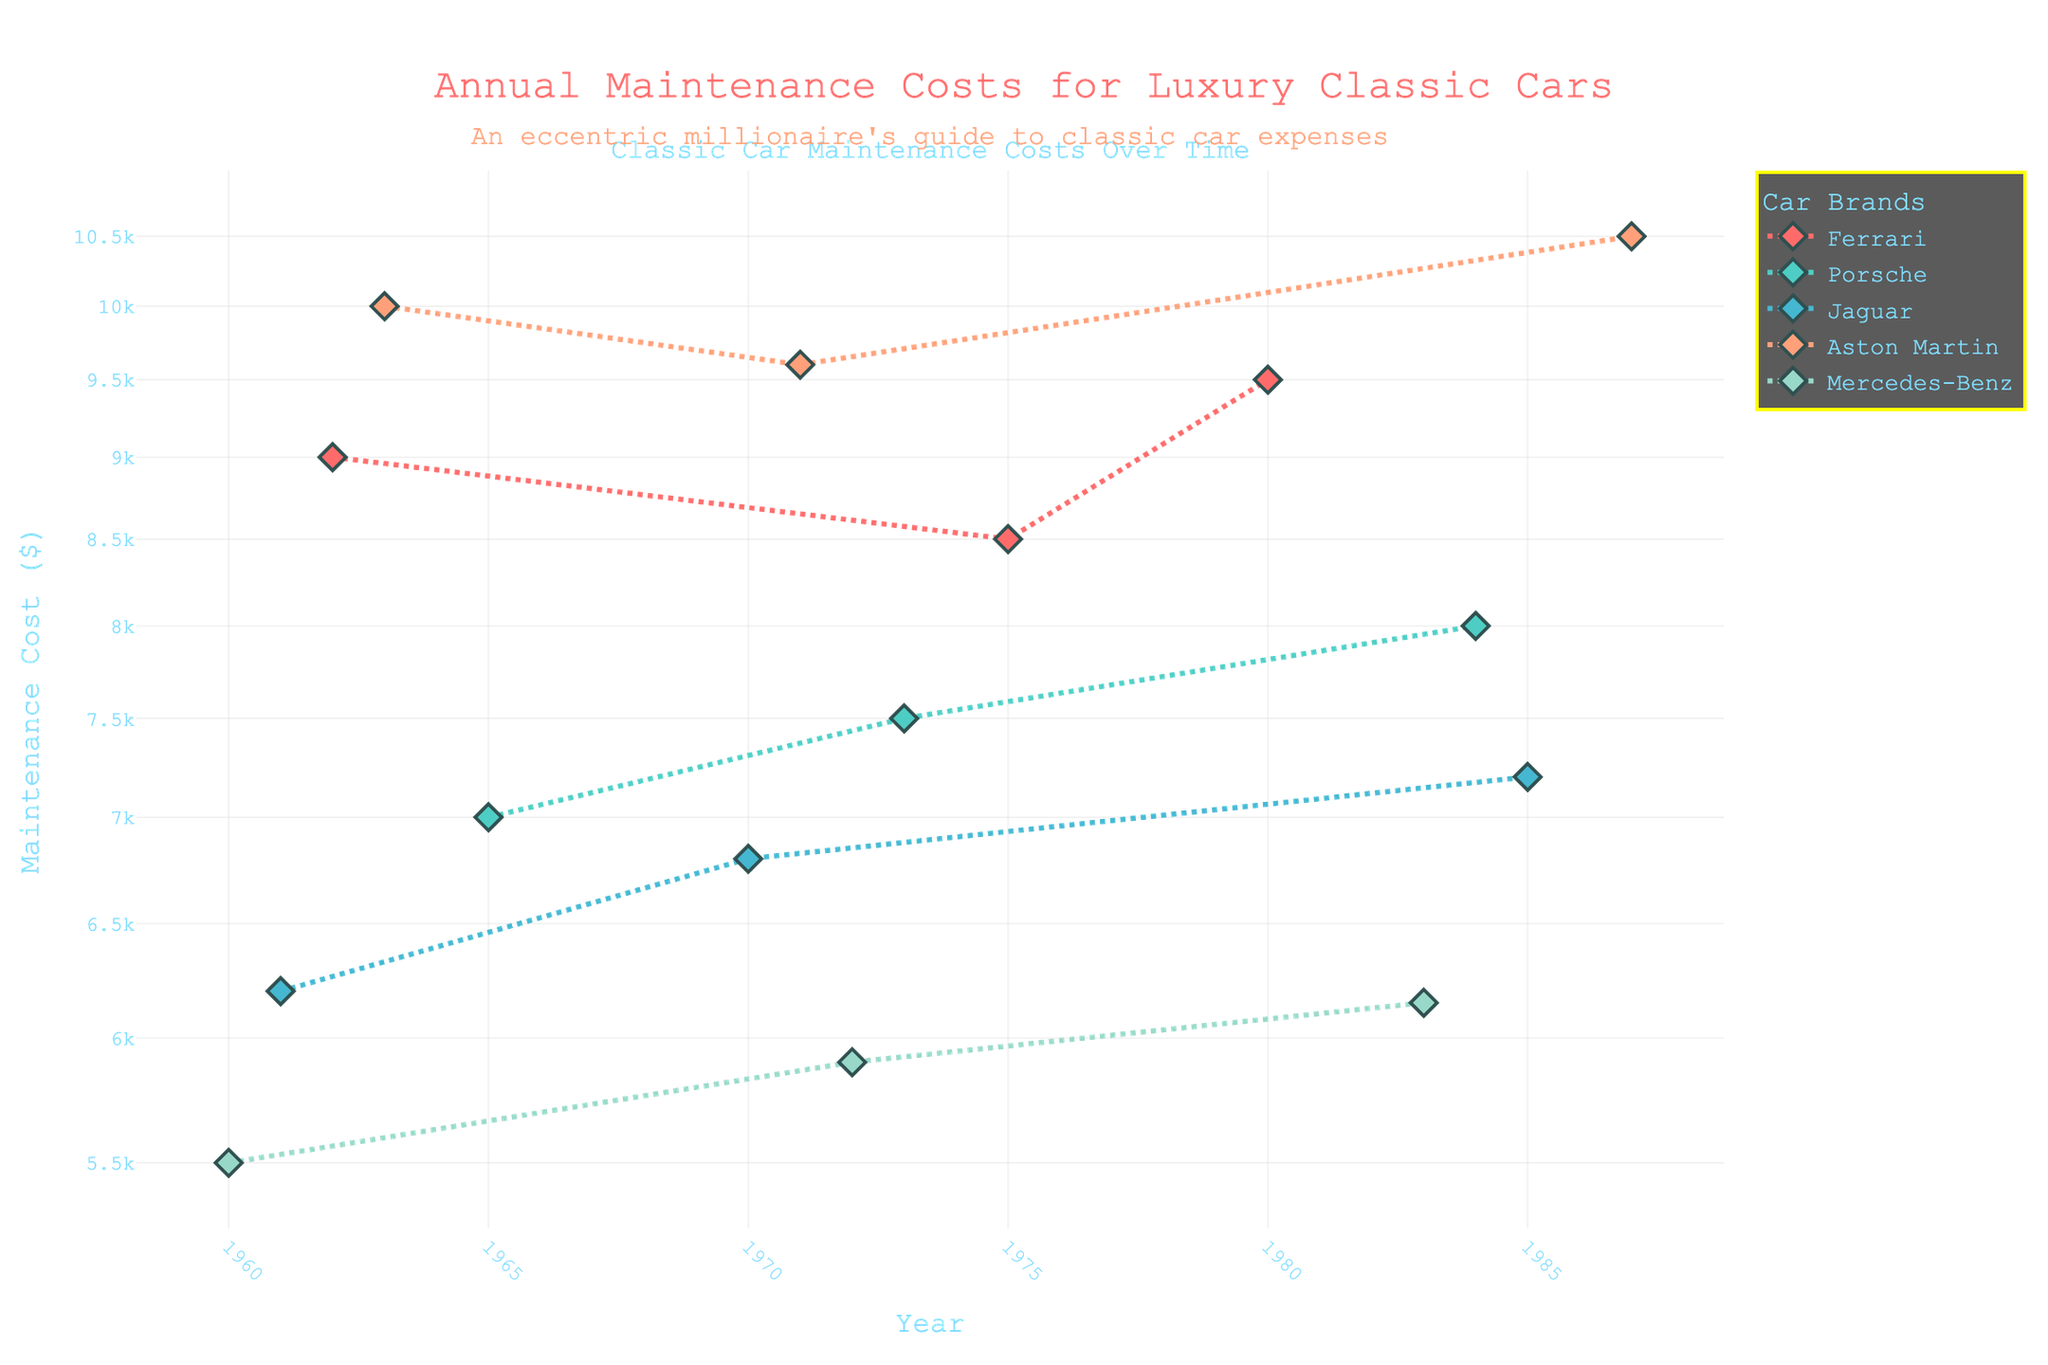What is the title of the plot? The title can be found at the top of the plot, usually centered.
Answer: Annual Maintenance Costs for Luxury Classic Cars Which brand has the highest maintenance cost in 1987? Locate the year 1987 on the x-axis and observe the y-axis to identify the highest point among the brands for that year.
Answer: Aston Martin How has the maintenance cost for Ferrari changed from 1962 to 1980? Compare the y-axis values for Ferrari data points in the years 1962 and 1980. Note the increase or decrease.
Answer: Increased What's the difference in maintenance cost between Porsche in 1965 and 1984? Identify the y-axis values for Porsche data points in the years 1965 and 1984, then calculate the difference.
Answer: 1000 Which two years have the closest maintenance costs for Jaguar? Compare all y-axis values for Jaguar and find two years with the smallest difference in their maintenance costs.
Answer: 1970 and 1985 Which brand has the most consistent maintenance costs over the years? Observe which brand has data points that align closest to a single horizontal line trajectory on the y-axis.
Answer: Mercedes-Benz Is there a year where maintenance costs for all brands were relatively low? Look at the plot and find a year where the y-axis values are comparably lower across all brands.
Answer: 1960 What is the log scale range of the y-axis? Check the y-axis for its minimum and maximum values expressed in a logarithmic scale.
Answer: 5500 to 10500 How do maintenance costs for Ferrari compare with Aston Martin in 1971? Find the y-axis values for both Ferrari and Aston Martin for the year 1971 and compare.
Answer: Ferrari is lower Which brand shows the highest increase in maintenance cost from 1960 to any later year? Calculate the differences between the earliest year and the highest subsequent year for each brand, then identify the brand with the highest increase.
Answer: Aston Martin 